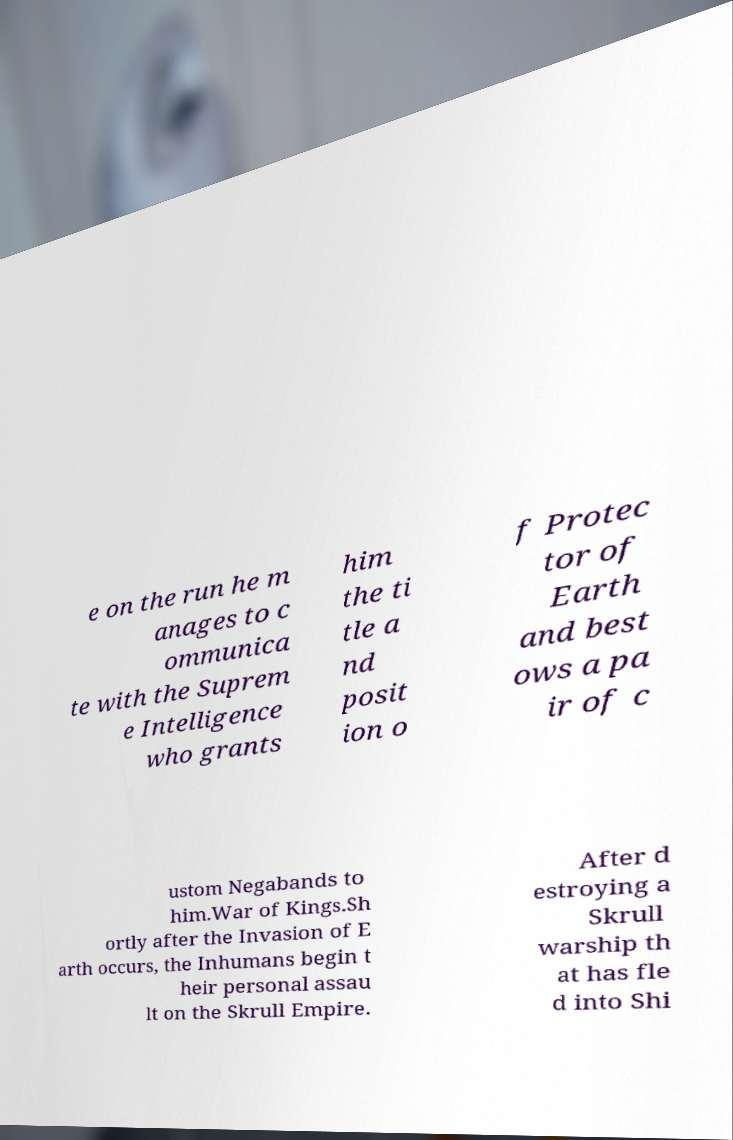I need the written content from this picture converted into text. Can you do that? e on the run he m anages to c ommunica te with the Suprem e Intelligence who grants him the ti tle a nd posit ion o f Protec tor of Earth and best ows a pa ir of c ustom Negabands to him.War of Kings.Sh ortly after the Invasion of E arth occurs, the Inhumans begin t heir personal assau lt on the Skrull Empire. After d estroying a Skrull warship th at has fle d into Shi 